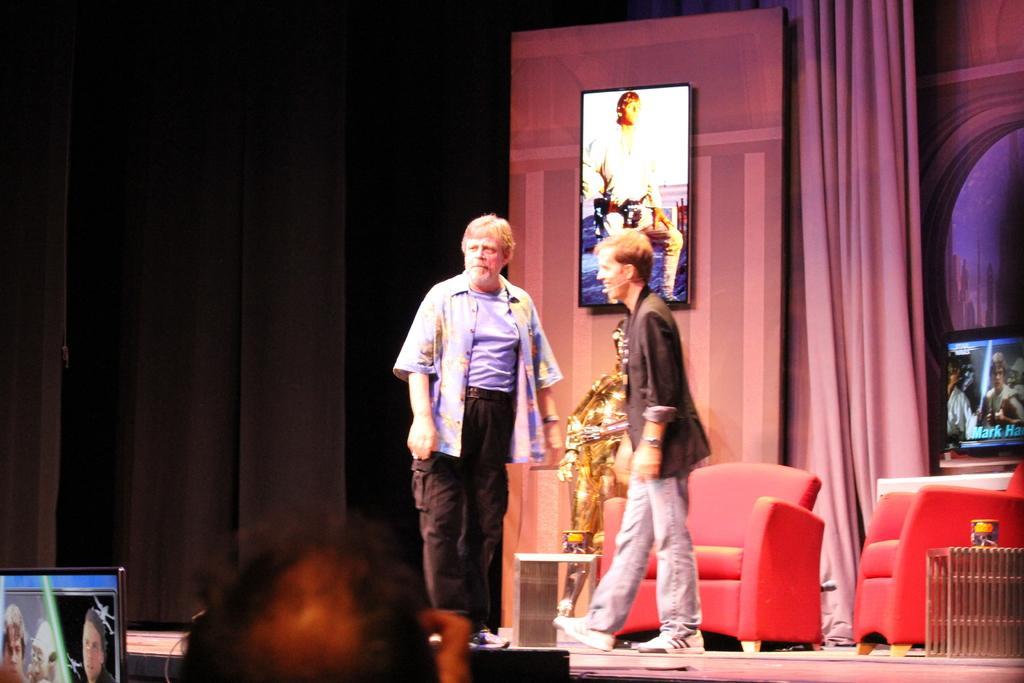Can you describe this image briefly? It is an event, on the stage there are two men and behind them there are two red sofas, behind one of the sofa there is a gold color sculpture and in the background there is a television and beside the television there is a curtain, in front of the curtain there is a poster and on the left side there is a black curtain, in front of the stage some people are gathered and the images of some people are being displayed on the screen in front of the audience. 